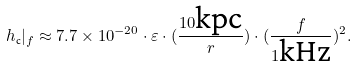Convert formula to latex. <formula><loc_0><loc_0><loc_500><loc_500>h _ { \text {c} } | _ { f } \approx 7 . 7 \times 1 0 ^ { - 2 0 } \cdot \varepsilon \cdot ( \frac { 1 0 \text {kpc} } { r } ) \cdot ( \frac { f } { 1 \text {kHz} } ) ^ { 2 } .</formula> 